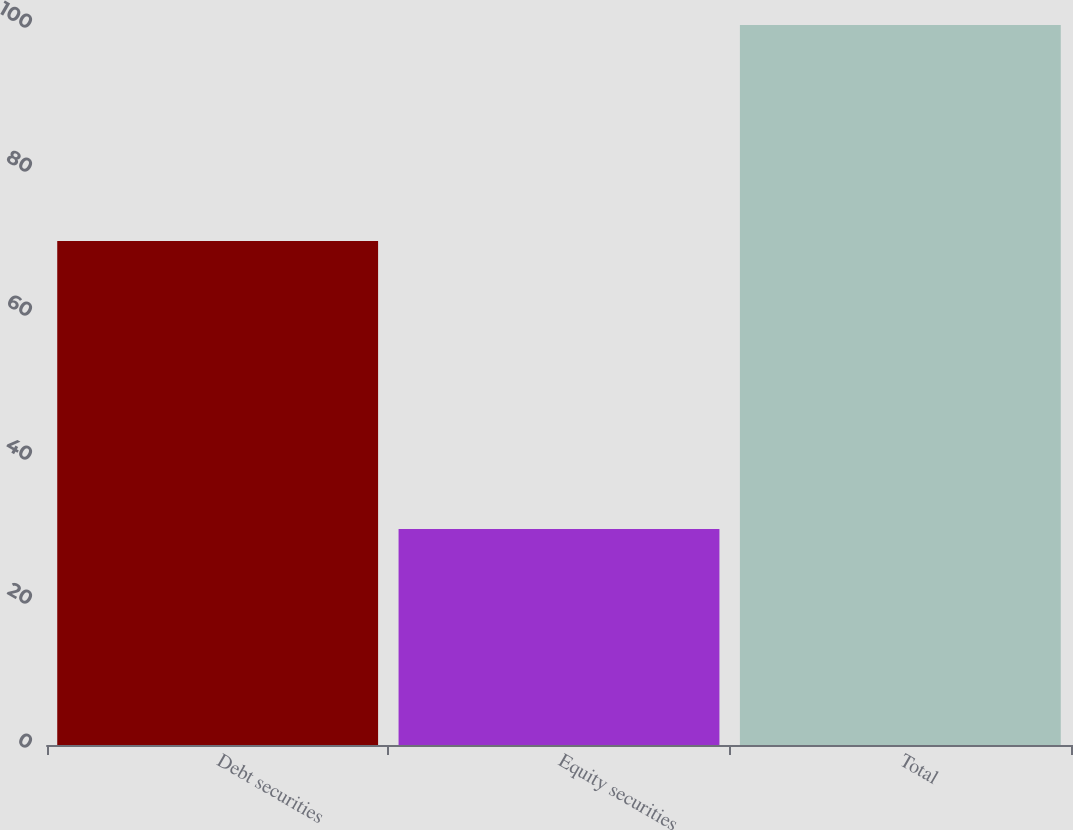<chart> <loc_0><loc_0><loc_500><loc_500><bar_chart><fcel>Debt securities<fcel>Equity securities<fcel>Total<nl><fcel>70<fcel>30<fcel>100<nl></chart> 